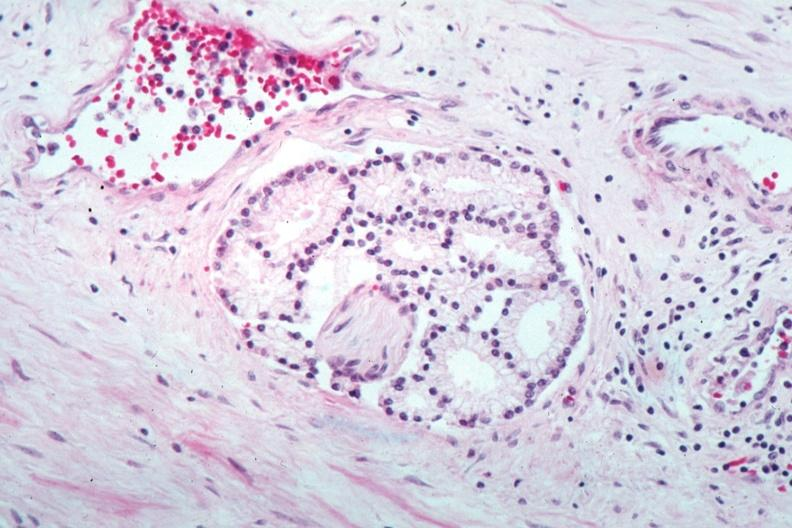s prostate present?
Answer the question using a single word or phrase. Yes 